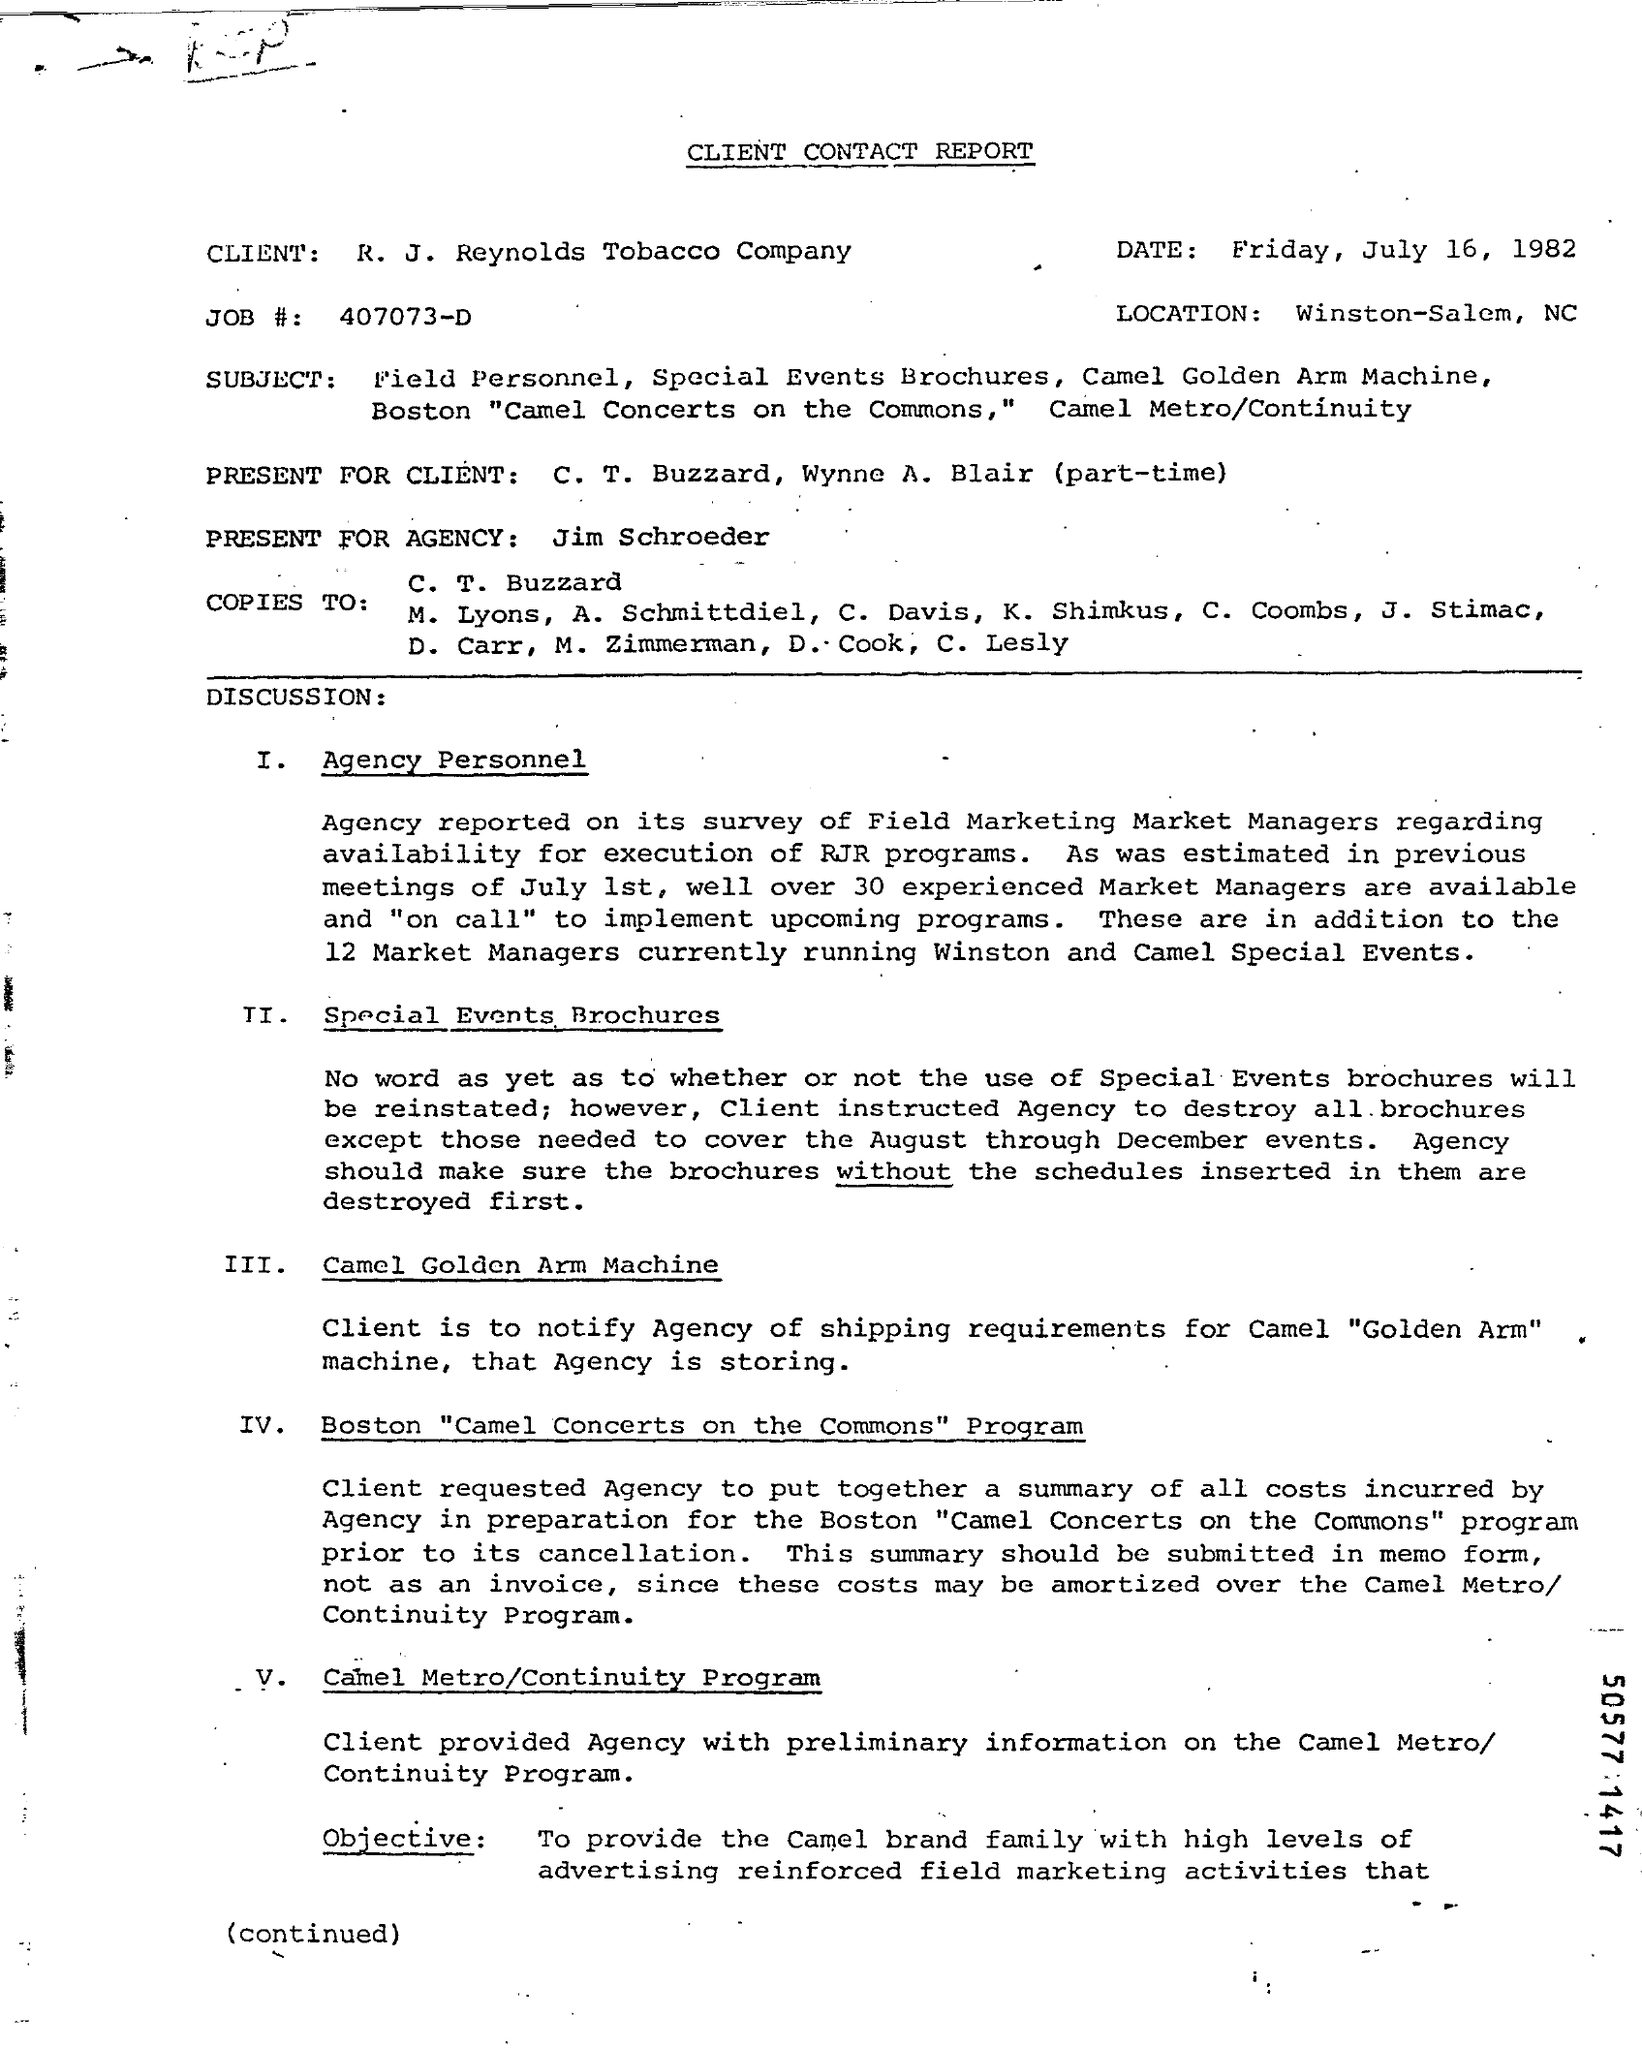Draw attention to some important aspects in this diagram. The job number is 407073-D. There is currently 12 market managers who are responsible for running Winston and Camel special events. 